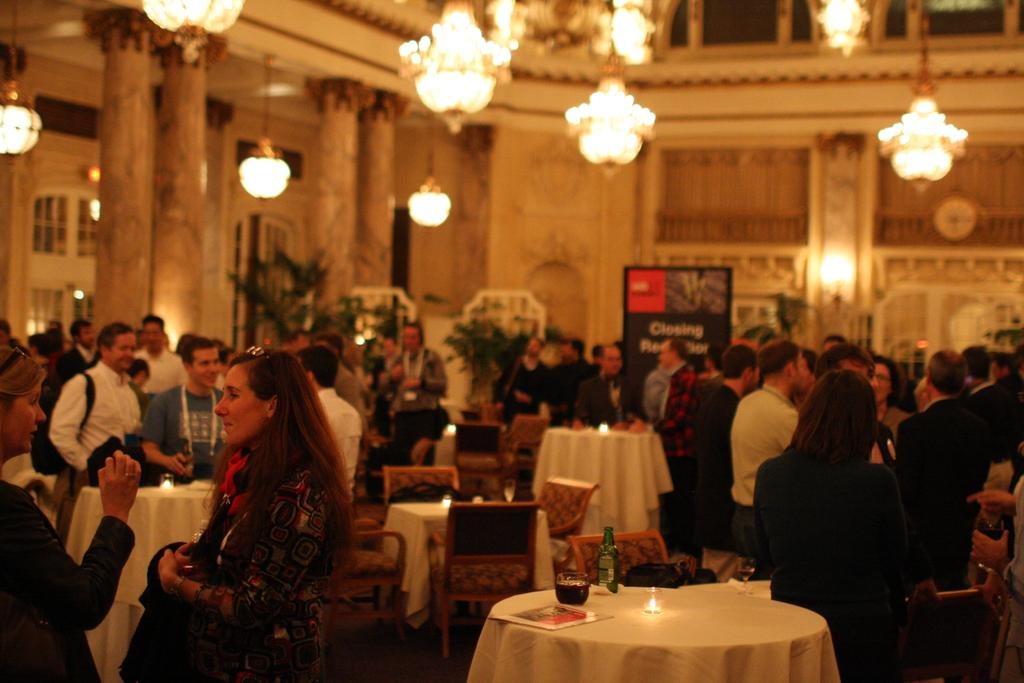What can be seen in the image? There are people standing in the image. What type of furniture is present in the image? There are tables and chairs in the image. Are there any fairies sitting on the tables in the image? No, there are no fairies present in the image. Which table has the pot with the queen's favorite flowers? There is no information about a pot or the queen's favorite flowers in the image. 